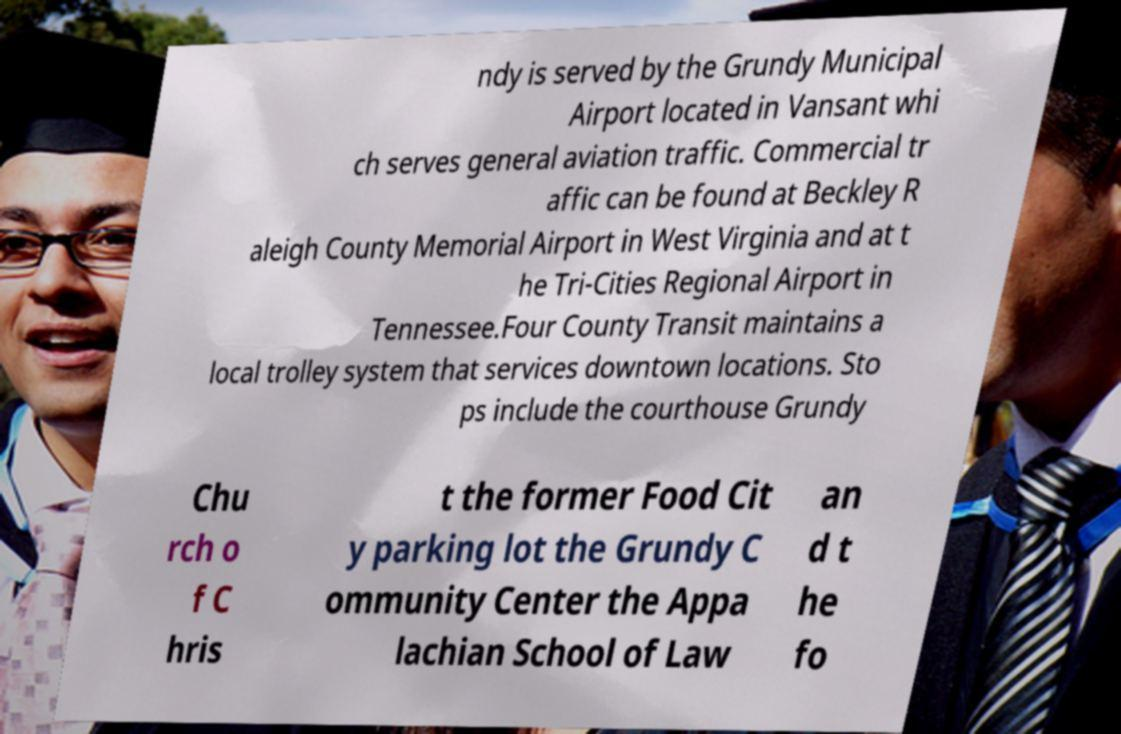Could you extract and type out the text from this image? ndy is served by the Grundy Municipal Airport located in Vansant whi ch serves general aviation traffic. Commercial tr affic can be found at Beckley R aleigh County Memorial Airport in West Virginia and at t he Tri-Cities Regional Airport in Tennessee.Four County Transit maintains a local trolley system that services downtown locations. Sto ps include the courthouse Grundy Chu rch o f C hris t the former Food Cit y parking lot the Grundy C ommunity Center the Appa lachian School of Law an d t he fo 